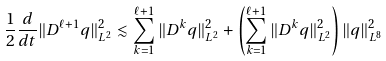Convert formula to latex. <formula><loc_0><loc_0><loc_500><loc_500>\frac { 1 } { 2 } \frac { d } { d t } \| D ^ { \ell + 1 } q \| _ { L ^ { 2 } } ^ { 2 } \lesssim \sum _ { k = 1 } ^ { \ell + 1 } \| D ^ { k } q \| _ { L ^ { 2 } } ^ { 2 } + \left ( \sum _ { k = 1 } ^ { \ell + 1 } \| D ^ { k } q \| _ { L ^ { 2 } } ^ { 2 } \right ) \| q \| _ { L ^ { 8 } } ^ { 2 }</formula> 